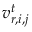<formula> <loc_0><loc_0><loc_500><loc_500>v _ { r , i , j } ^ { t }</formula> 